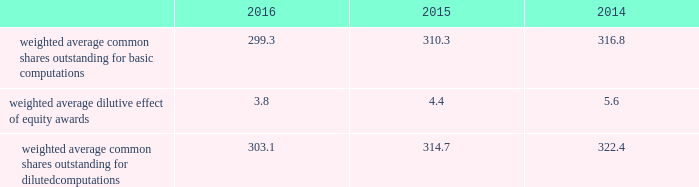Benefits as an increase to earnings of $ 152 million ( $ 0.50 per share ) during the year ended december 31 , 2016 .
Additionally , we recognized additional income tax benefits as an increase to operating cash flows of $ 152 million during the year ended december 31 , 2016 .
The new accounting standard did not impact any periods prior to january 1 , 2016 , as we applied the changes in the asu on a prospective basis .
In september 2015 , the fasb issued asu no .
2015-16 , business combinations ( topic 805 ) , which simplifies the accounting for adjustments made to preliminary amounts recognized in a business combination by eliminating the requirement to retrospectively account for those adjustments .
Instead , adjustments will be recognized in the period in which the adjustments are determined , including the effect on earnings of any amounts that would have been recorded in previous periods if the accounting had been completed at the acquisition date .
We adopted the asu on january 1 , 2016 and are prospectively applying the asu to business combination adjustments identified after the date of adoption .
In november 2015 , the fasb issued asu no .
2015-17 , income taxes ( topic 740 ) , which simplifies the presentation of deferred income taxes and requires that deferred tax assets and liabilities , as well as any related valuation allowance , be classified as noncurrent in our consolidated balance sheets .
We applied the provisions of the asu retrospectively and reclassified approximately $ 1.6 billion from current to noncurrent assets and approximately $ 140 million from current to noncurrent liabilities in our consolidated balance sheet as of december 31 , 2015 .
Note 2 2013 earnings per share the weighted average number of shares outstanding used to compute earnings per common share were as follows ( in millions ) : .
We compute basic and diluted earnings per common share by dividing net earnings by the respective weighted average number of common shares outstanding for the periods presented .
Our calculation of diluted earnings per common share also includes the dilutive effects for the assumed vesting of outstanding restricted stock units and exercise of outstanding stock options based on the treasury stock method .
There were no anti-dilutive equity awards for the years ended december 31 , 2016 , 2015 and 2014 .
Note 3 2013 acquisitions and divestitures acquisitions acquisition of sikorsky aircraft corporation on november 6 , 2015 , we completed the acquisition of sikorsky aircraft corporation and certain affiliated companies ( collectively 201csikorsky 201d ) from united technologies corporation ( utc ) and certain of utc 2019s subsidiaries .
The purchase price of the acquisition was $ 9.0 billion , net of cash acquired .
As a result of the acquisition , sikorsky became a wholly- owned subsidiary of ours .
Sikorsky is a global company primarily engaged in the research , design , development , manufacture and support of military and commercial helicopters .
Sikorsky 2019s products include military helicopters such as the black hawk , seahawk , ch-53k , h-92 ; and commercial helicopters such as the s-76 and s-92 .
The acquisition enables us to extend our core business into the military and commercial rotary wing markets , allowing us to strengthen our position in the aerospace and defense industry .
Further , this acquisition will expand our presence in commercial and international markets .
Sikorsky has been aligned under our rms business segment .
To fund the $ 9.0 billion acquisition price , we utilized $ 6.0 billion of proceeds borrowed under a temporary 364-day revolving credit facility ( the 364-day facility ) , $ 2.0 billion of cash on hand and $ 1.0 billion from the issuance of commercial paper .
In the fourth quarter of 2015 , we repaid all outstanding borrowings under the 364-day facility with the proceeds from the issuance of $ 7.0 billion of fixed interest-rate long-term notes in a public offering ( the november 2015 notes ) .
In the fourth quarter of 2015 , we also repaid the $ 1.0 billion in commercial paper borrowings ( see 201cnote 10 2013 debt 201d ) . .
What is the percentage change in weighted average common shares outstanding for diluted computations from 2015 to 2016? 
Computations: ((303.1 - 314.7) / 314.7)
Answer: -0.03686. 